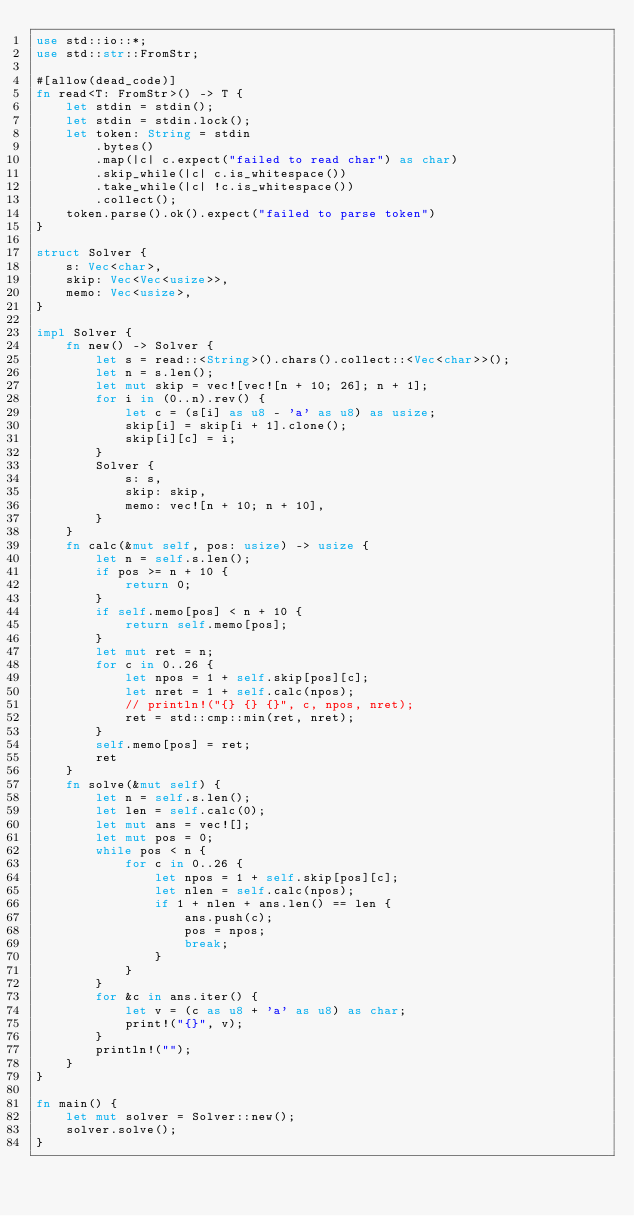<code> <loc_0><loc_0><loc_500><loc_500><_Rust_>use std::io::*;
use std::str::FromStr;

#[allow(dead_code)]
fn read<T: FromStr>() -> T {
    let stdin = stdin();
    let stdin = stdin.lock();
    let token: String = stdin
        .bytes()
        .map(|c| c.expect("failed to read char") as char)
        .skip_while(|c| c.is_whitespace())
        .take_while(|c| !c.is_whitespace())
        .collect();
    token.parse().ok().expect("failed to parse token")
}

struct Solver {
    s: Vec<char>,
    skip: Vec<Vec<usize>>,
    memo: Vec<usize>,
}

impl Solver {
    fn new() -> Solver {
        let s = read::<String>().chars().collect::<Vec<char>>();
        let n = s.len();
        let mut skip = vec![vec![n + 10; 26]; n + 1];
        for i in (0..n).rev() {
            let c = (s[i] as u8 - 'a' as u8) as usize;
            skip[i] = skip[i + 1].clone();
            skip[i][c] = i;
        }
        Solver {
            s: s,
            skip: skip,
            memo: vec![n + 10; n + 10],
        }
    }
    fn calc(&mut self, pos: usize) -> usize {
        let n = self.s.len();
        if pos >= n + 10 {
            return 0;
        }
        if self.memo[pos] < n + 10 {
            return self.memo[pos];
        }
        let mut ret = n;
        for c in 0..26 {
            let npos = 1 + self.skip[pos][c];
            let nret = 1 + self.calc(npos);
            // println!("{} {} {}", c, npos, nret);
            ret = std::cmp::min(ret, nret);
        }
        self.memo[pos] = ret;
        ret
    }
    fn solve(&mut self) {
        let n = self.s.len();
        let len = self.calc(0);
        let mut ans = vec![];
        let mut pos = 0;
        while pos < n {
            for c in 0..26 {
                let npos = 1 + self.skip[pos][c];
                let nlen = self.calc(npos);
                if 1 + nlen + ans.len() == len {
                    ans.push(c);
                    pos = npos;
                    break;
                }
            }
        }
        for &c in ans.iter() {
            let v = (c as u8 + 'a' as u8) as char;
            print!("{}", v);
        }
        println!("");
    }
}

fn main() {
    let mut solver = Solver::new();
    solver.solve();
}
</code> 